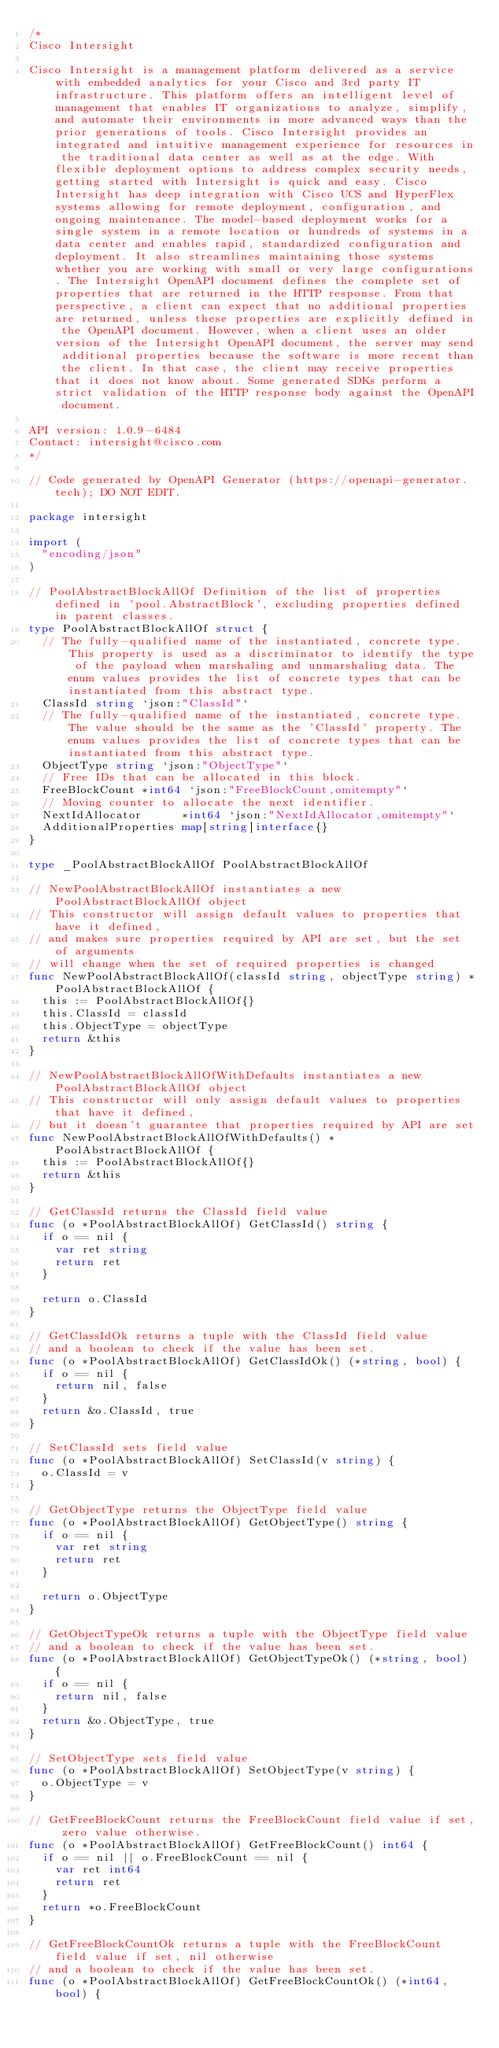<code> <loc_0><loc_0><loc_500><loc_500><_Go_>/*
Cisco Intersight

Cisco Intersight is a management platform delivered as a service with embedded analytics for your Cisco and 3rd party IT infrastructure. This platform offers an intelligent level of management that enables IT organizations to analyze, simplify, and automate their environments in more advanced ways than the prior generations of tools. Cisco Intersight provides an integrated and intuitive management experience for resources in the traditional data center as well as at the edge. With flexible deployment options to address complex security needs, getting started with Intersight is quick and easy. Cisco Intersight has deep integration with Cisco UCS and HyperFlex systems allowing for remote deployment, configuration, and ongoing maintenance. The model-based deployment works for a single system in a remote location or hundreds of systems in a data center and enables rapid, standardized configuration and deployment. It also streamlines maintaining those systems whether you are working with small or very large configurations. The Intersight OpenAPI document defines the complete set of properties that are returned in the HTTP response. From that perspective, a client can expect that no additional properties are returned, unless these properties are explicitly defined in the OpenAPI document. However, when a client uses an older version of the Intersight OpenAPI document, the server may send additional properties because the software is more recent than the client. In that case, the client may receive properties that it does not know about. Some generated SDKs perform a strict validation of the HTTP response body against the OpenAPI document.

API version: 1.0.9-6484
Contact: intersight@cisco.com
*/

// Code generated by OpenAPI Generator (https://openapi-generator.tech); DO NOT EDIT.

package intersight

import (
	"encoding/json"
)

// PoolAbstractBlockAllOf Definition of the list of properties defined in 'pool.AbstractBlock', excluding properties defined in parent classes.
type PoolAbstractBlockAllOf struct {
	// The fully-qualified name of the instantiated, concrete type. This property is used as a discriminator to identify the type of the payload when marshaling and unmarshaling data. The enum values provides the list of concrete types that can be instantiated from this abstract type.
	ClassId string `json:"ClassId"`
	// The fully-qualified name of the instantiated, concrete type. The value should be the same as the 'ClassId' property. The enum values provides the list of concrete types that can be instantiated from this abstract type.
	ObjectType string `json:"ObjectType"`
	// Free IDs that can be allocated in this block.
	FreeBlockCount *int64 `json:"FreeBlockCount,omitempty"`
	// Moving counter to allocate the next identifier.
	NextIdAllocator      *int64 `json:"NextIdAllocator,omitempty"`
	AdditionalProperties map[string]interface{}
}

type _PoolAbstractBlockAllOf PoolAbstractBlockAllOf

// NewPoolAbstractBlockAllOf instantiates a new PoolAbstractBlockAllOf object
// This constructor will assign default values to properties that have it defined,
// and makes sure properties required by API are set, but the set of arguments
// will change when the set of required properties is changed
func NewPoolAbstractBlockAllOf(classId string, objectType string) *PoolAbstractBlockAllOf {
	this := PoolAbstractBlockAllOf{}
	this.ClassId = classId
	this.ObjectType = objectType
	return &this
}

// NewPoolAbstractBlockAllOfWithDefaults instantiates a new PoolAbstractBlockAllOf object
// This constructor will only assign default values to properties that have it defined,
// but it doesn't guarantee that properties required by API are set
func NewPoolAbstractBlockAllOfWithDefaults() *PoolAbstractBlockAllOf {
	this := PoolAbstractBlockAllOf{}
	return &this
}

// GetClassId returns the ClassId field value
func (o *PoolAbstractBlockAllOf) GetClassId() string {
	if o == nil {
		var ret string
		return ret
	}

	return o.ClassId
}

// GetClassIdOk returns a tuple with the ClassId field value
// and a boolean to check if the value has been set.
func (o *PoolAbstractBlockAllOf) GetClassIdOk() (*string, bool) {
	if o == nil {
		return nil, false
	}
	return &o.ClassId, true
}

// SetClassId sets field value
func (o *PoolAbstractBlockAllOf) SetClassId(v string) {
	o.ClassId = v
}

// GetObjectType returns the ObjectType field value
func (o *PoolAbstractBlockAllOf) GetObjectType() string {
	if o == nil {
		var ret string
		return ret
	}

	return o.ObjectType
}

// GetObjectTypeOk returns a tuple with the ObjectType field value
// and a boolean to check if the value has been set.
func (o *PoolAbstractBlockAllOf) GetObjectTypeOk() (*string, bool) {
	if o == nil {
		return nil, false
	}
	return &o.ObjectType, true
}

// SetObjectType sets field value
func (o *PoolAbstractBlockAllOf) SetObjectType(v string) {
	o.ObjectType = v
}

// GetFreeBlockCount returns the FreeBlockCount field value if set, zero value otherwise.
func (o *PoolAbstractBlockAllOf) GetFreeBlockCount() int64 {
	if o == nil || o.FreeBlockCount == nil {
		var ret int64
		return ret
	}
	return *o.FreeBlockCount
}

// GetFreeBlockCountOk returns a tuple with the FreeBlockCount field value if set, nil otherwise
// and a boolean to check if the value has been set.
func (o *PoolAbstractBlockAllOf) GetFreeBlockCountOk() (*int64, bool) {</code> 